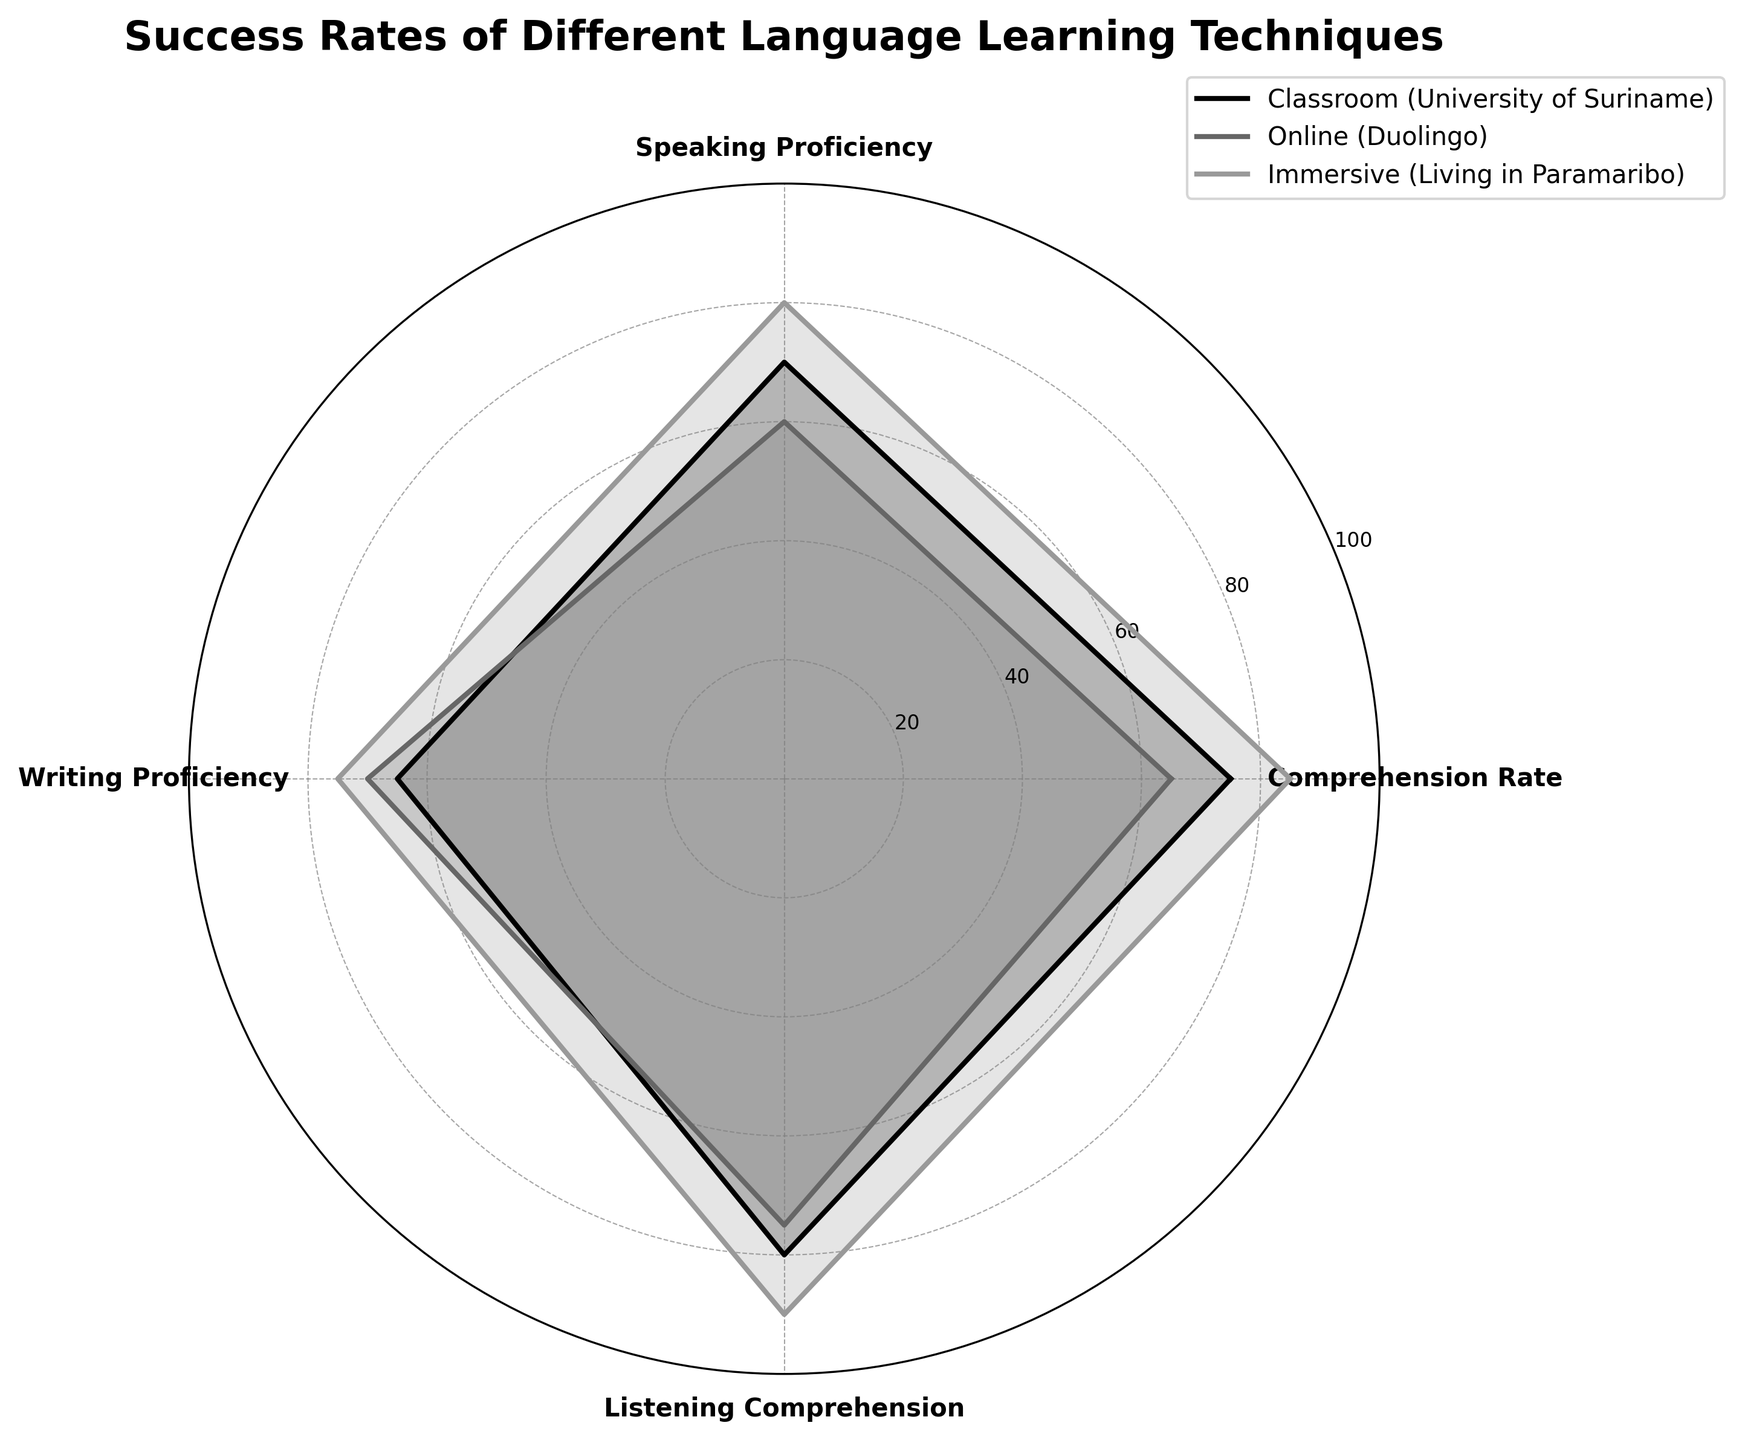What are the techniques compared in the radar chart? The radar chart labels show three techniques compared: Classroom (University of Suriname), Online (Duolingo), and Immersive (Living in Paramaribo).
Answer: Classroom (University of Suriname), Online (Duolingo), Immersive (Living in Paramaribo) Which language learning technique has the highest comprehension rate? The radar chart shows the comprehension rates. The Immersive technique has the highest comprehension rate at 85%.
Answer: Immersive What is the average writing proficiency across all techniques? Add the writing proficiency values for all techniques and divide by the number of techniques: (65 + 70 + 75) / 3 equals 70.
Answer: 70 How does the speaking proficiency of Online compare to Classroom? The radar chart shows that Speaking Proficiency is 60 for Online and 70 for Classroom. Online is 10 points lower than Classroom.
Answer: 10 points lower Which technique excels the most in listening comprehension? The radar chart indicates the listening comprehension scores: Classroom is 80, Online is 75, Immersive is 90. Immersive excels the most.
Answer: Immersive What are the values for comprehension rate in the Classroom technique? The radar chart shows the Classroom comprehension rate as 75.
Answer: 75 Is there any skill where the Classroom technique scores the lowest compared to the other techniques? The radar chart shows the scores for each skill. Classroom technique scores the lowest in Writing Proficiency (65) compared to Online (70) and Immersive (75).
Answer: Yes, Writing Proficiency What is the total of all the comprehension rates for all techniques? Sum the comprehension rates across all techniques: 75 + 65 + 85 equals 225.
Answer: 225 